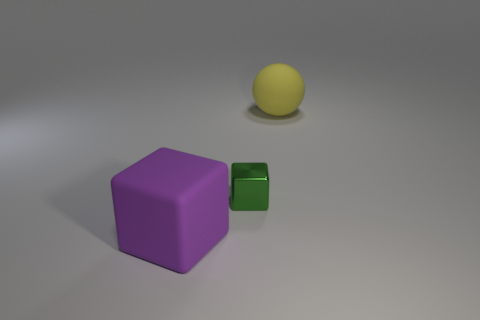There is a thing that is in front of the large rubber sphere and to the right of the big block; what is its shape?
Offer a terse response. Cube. What is the color of the big rubber object behind the small green cube?
Your response must be concise. Yellow. There is a thing that is behind the large block and to the left of the big yellow matte thing; how big is it?
Ensure brevity in your answer.  Small. Are the big ball and the block that is behind the large cube made of the same material?
Offer a very short reply. No. What number of other large things have the same shape as the shiny thing?
Provide a succinct answer. 1. What number of big rubber balls are there?
Ensure brevity in your answer.  1. There is a tiny green metal thing; does it have the same shape as the rubber thing on the left side of the matte ball?
Provide a short and direct response. Yes. What number of things are green blocks or objects that are left of the large yellow matte sphere?
Make the answer very short. 2. There is a tiny object that is the same shape as the big purple object; what is its material?
Your answer should be compact. Metal. There is a matte object that is left of the yellow object; is its shape the same as the shiny object?
Your answer should be very brief. Yes. 